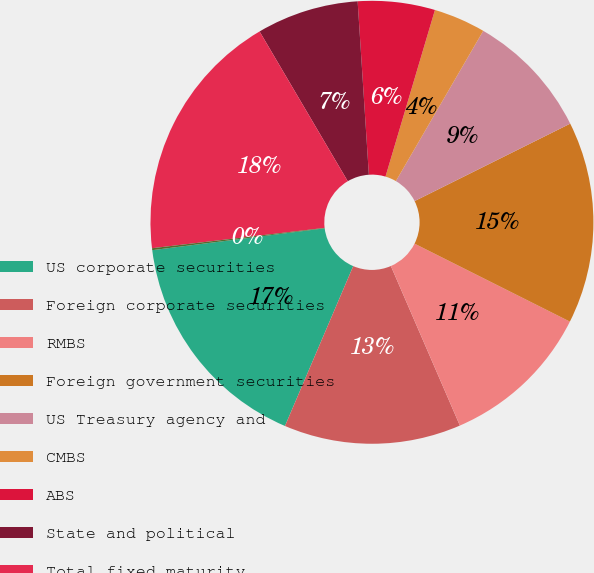Convert chart. <chart><loc_0><loc_0><loc_500><loc_500><pie_chart><fcel>US corporate securities<fcel>Foreign corporate securities<fcel>RMBS<fcel>Foreign government securities<fcel>US Treasury agency and<fcel>CMBS<fcel>ABS<fcel>State and political<fcel>Total fixed maturity<fcel>Non-redeemable preferred stock<nl><fcel>16.57%<fcel>12.92%<fcel>11.1%<fcel>14.75%<fcel>9.27%<fcel>3.79%<fcel>5.62%<fcel>7.44%<fcel>18.4%<fcel>0.14%<nl></chart> 